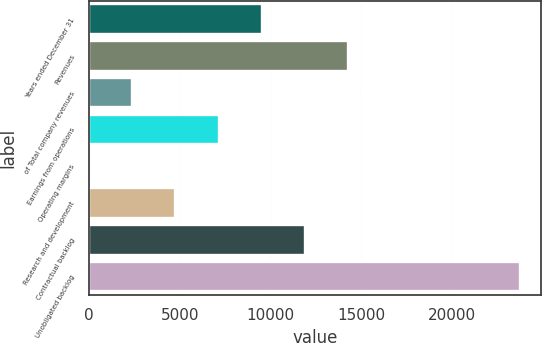<chart> <loc_0><loc_0><loc_500><loc_500><bar_chart><fcel>Years ended December 31<fcel>Revenues<fcel>of Total company revenues<fcel>Earnings from operations<fcel>Operating margins<fcel>Research and development<fcel>Contractual backlog<fcel>Unobligated backlog<nl><fcel>9506.74<fcel>14256.2<fcel>2382.61<fcel>7132.03<fcel>7.9<fcel>4757.32<fcel>11881.5<fcel>23755<nl></chart> 